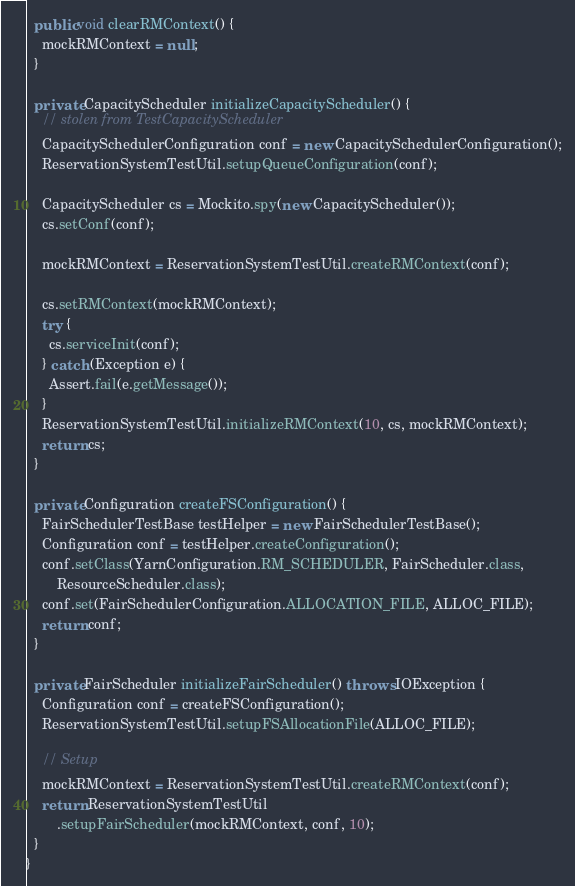Convert code to text. <code><loc_0><loc_0><loc_500><loc_500><_Java_>
  public void clearRMContext() {
    mockRMContext = null;
  }

  private CapacityScheduler initializeCapacityScheduler() {
    // stolen from TestCapacityScheduler
    CapacitySchedulerConfiguration conf = new CapacitySchedulerConfiguration();
    ReservationSystemTestUtil.setupQueueConfiguration(conf);

    CapacityScheduler cs = Mockito.spy(new CapacityScheduler());
    cs.setConf(conf);

    mockRMContext = ReservationSystemTestUtil.createRMContext(conf);

    cs.setRMContext(mockRMContext);
    try {
      cs.serviceInit(conf);
    } catch (Exception e) {
      Assert.fail(e.getMessage());
    }
    ReservationSystemTestUtil.initializeRMContext(10, cs, mockRMContext);
    return cs;
  }

  private Configuration createFSConfiguration() {
    FairSchedulerTestBase testHelper = new FairSchedulerTestBase();
    Configuration conf = testHelper.createConfiguration();
    conf.setClass(YarnConfiguration.RM_SCHEDULER, FairScheduler.class,
        ResourceScheduler.class);
    conf.set(FairSchedulerConfiguration.ALLOCATION_FILE, ALLOC_FILE);
    return conf;
  }

  private FairScheduler initializeFairScheduler() throws IOException {
    Configuration conf = createFSConfiguration();
    ReservationSystemTestUtil.setupFSAllocationFile(ALLOC_FILE);

    // Setup
    mockRMContext = ReservationSystemTestUtil.createRMContext(conf);
    return ReservationSystemTestUtil
        .setupFairScheduler(mockRMContext, conf, 10);
  }
}
</code> 